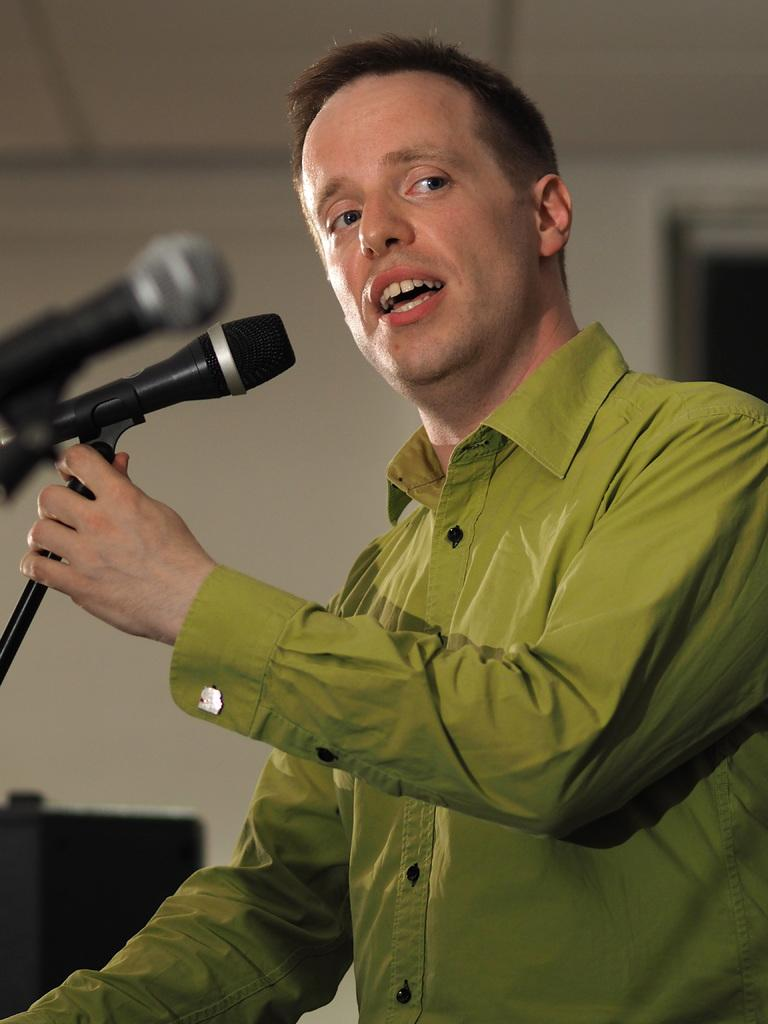What is the man in the image doing? The man is standing at the mics in the image. What can be seen in the background of the image? There is a wall and a door in the background of the image. How many frogs are sitting on the quilt in the image? There are no frogs or quilts present in the image. 